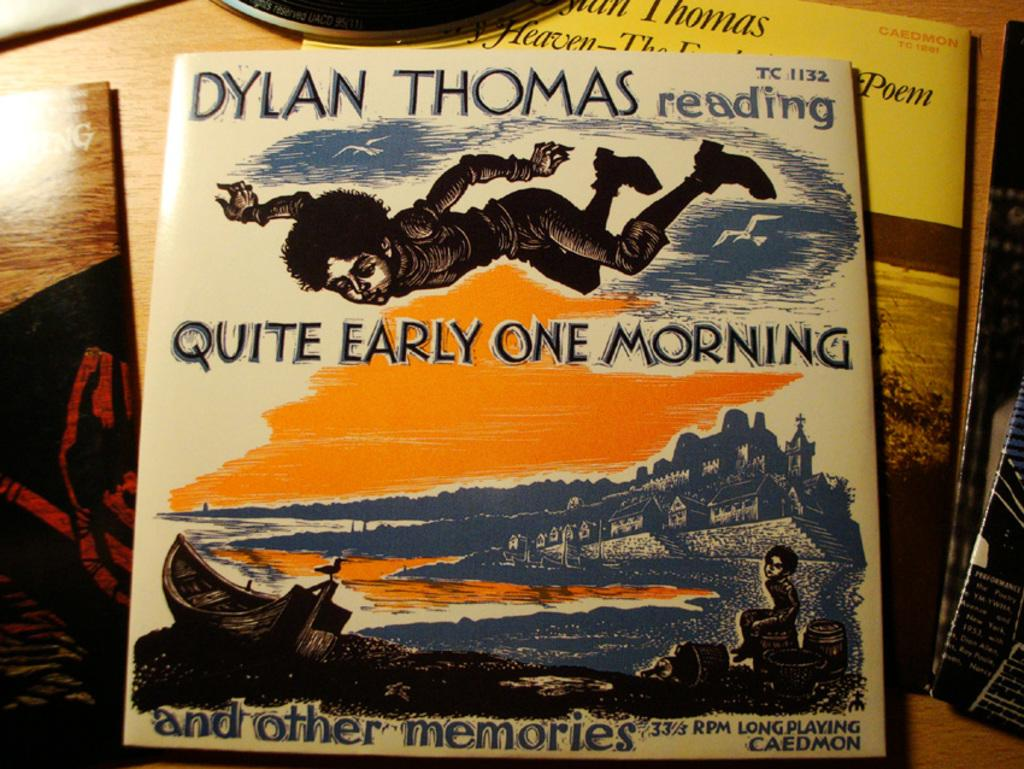<image>
Relay a brief, clear account of the picture shown. a book that was made by Dylan Thomas 